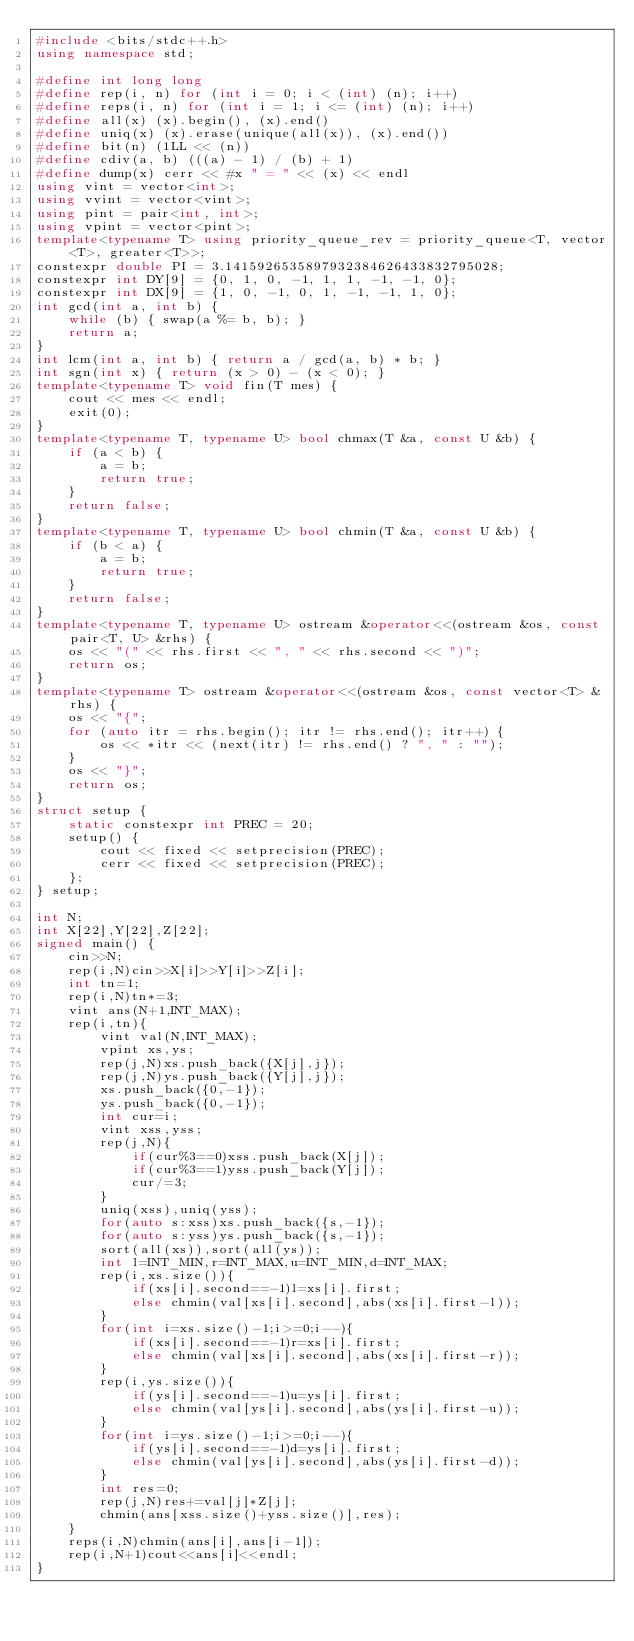<code> <loc_0><loc_0><loc_500><loc_500><_C++_>#include <bits/stdc++.h>
using namespace std;

#define int long long
#define rep(i, n) for (int i = 0; i < (int) (n); i++)
#define reps(i, n) for (int i = 1; i <= (int) (n); i++)
#define all(x) (x).begin(), (x).end()
#define uniq(x) (x).erase(unique(all(x)), (x).end())
#define bit(n) (1LL << (n))
#define cdiv(a, b) (((a) - 1) / (b) + 1)
#define dump(x) cerr << #x " = " << (x) << endl
using vint = vector<int>;
using vvint = vector<vint>;
using pint = pair<int, int>;
using vpint = vector<pint>;
template<typename T> using priority_queue_rev = priority_queue<T, vector<T>, greater<T>>;
constexpr double PI = 3.1415926535897932384626433832795028;
constexpr int DY[9] = {0, 1, 0, -1, 1, 1, -1, -1, 0};
constexpr int DX[9] = {1, 0, -1, 0, 1, -1, -1, 1, 0};
int gcd(int a, int b) {
    while (b) { swap(a %= b, b); }
    return a;
}
int lcm(int a, int b) { return a / gcd(a, b) * b; }
int sgn(int x) { return (x > 0) - (x < 0); }
template<typename T> void fin(T mes) {
    cout << mes << endl;
    exit(0);
}
template<typename T, typename U> bool chmax(T &a, const U &b) {
    if (a < b) {
        a = b;
        return true;
    }
    return false;
}
template<typename T, typename U> bool chmin(T &a, const U &b) {
    if (b < a) {
        a = b;
        return true;
    }
    return false;
}
template<typename T, typename U> ostream &operator<<(ostream &os, const pair<T, U> &rhs) {
    os << "(" << rhs.first << ", " << rhs.second << ")";
    return os;
}
template<typename T> ostream &operator<<(ostream &os, const vector<T> &rhs) {
    os << "{";
    for (auto itr = rhs.begin(); itr != rhs.end(); itr++) {
        os << *itr << (next(itr) != rhs.end() ? ", " : "");
    }
    os << "}";
    return os;
}
struct setup {
    static constexpr int PREC = 20;
    setup() {
        cout << fixed << setprecision(PREC);
        cerr << fixed << setprecision(PREC);
    };
} setup;

int N;
int X[22],Y[22],Z[22];
signed main() {
    cin>>N;
    rep(i,N)cin>>X[i]>>Y[i]>>Z[i];
    int tn=1;
    rep(i,N)tn*=3;
    vint ans(N+1,INT_MAX);
    rep(i,tn){
        vint val(N,INT_MAX); 
        vpint xs,ys;
        rep(j,N)xs.push_back({X[j],j});
        rep(j,N)ys.push_back({Y[j],j});
        xs.push_back({0,-1});
        ys.push_back({0,-1});
        int cur=i;
        vint xss,yss;
        rep(j,N){
            if(cur%3==0)xss.push_back(X[j]);
            if(cur%3==1)yss.push_back(Y[j]);
            cur/=3;
        }
        uniq(xss),uniq(yss);
        for(auto s:xss)xs.push_back({s,-1});
        for(auto s:yss)ys.push_back({s,-1});
        sort(all(xs)),sort(all(ys));
        int l=INT_MIN,r=INT_MAX,u=INT_MIN,d=INT_MAX;
        rep(i,xs.size()){
            if(xs[i].second==-1)l=xs[i].first;
            else chmin(val[xs[i].second],abs(xs[i].first-l));
        }
        for(int i=xs.size()-1;i>=0;i--){
            if(xs[i].second==-1)r=xs[i].first;
            else chmin(val[xs[i].second],abs(xs[i].first-r));
        }
        rep(i,ys.size()){
            if(ys[i].second==-1)u=ys[i].first;
            else chmin(val[ys[i].second],abs(ys[i].first-u));
        }
        for(int i=ys.size()-1;i>=0;i--){
            if(ys[i].second==-1)d=ys[i].first;
            else chmin(val[ys[i].second],abs(ys[i].first-d));
        }
        int res=0;
        rep(j,N)res+=val[j]*Z[j];
        chmin(ans[xss.size()+yss.size()],res);
    }
    reps(i,N)chmin(ans[i],ans[i-1]);
    rep(i,N+1)cout<<ans[i]<<endl;
}</code> 